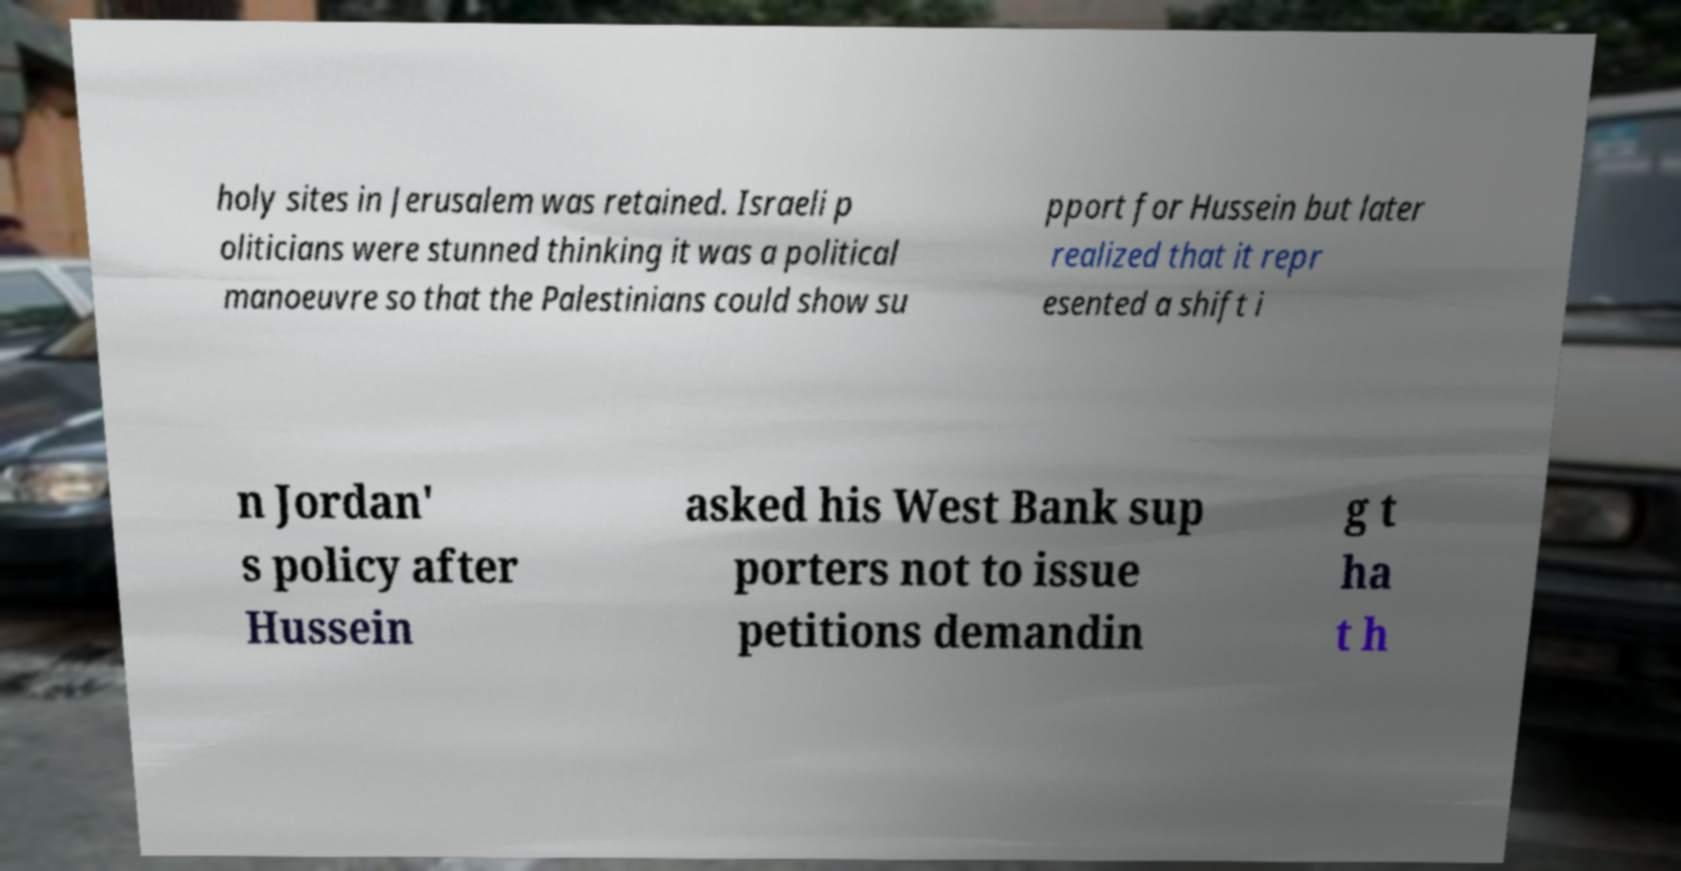Can you accurately transcribe the text from the provided image for me? holy sites in Jerusalem was retained. Israeli p oliticians were stunned thinking it was a political manoeuvre so that the Palestinians could show su pport for Hussein but later realized that it repr esented a shift i n Jordan' s policy after Hussein asked his West Bank sup porters not to issue petitions demandin g t ha t h 